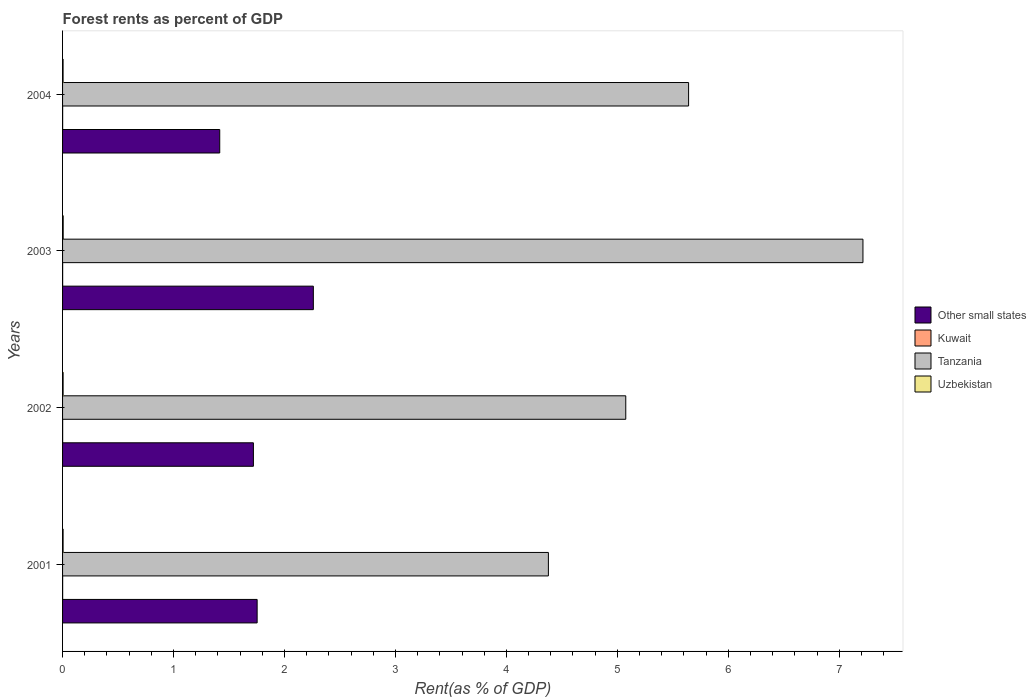How many groups of bars are there?
Make the answer very short. 4. Are the number of bars on each tick of the Y-axis equal?
Ensure brevity in your answer.  Yes. In how many cases, is the number of bars for a given year not equal to the number of legend labels?
Your answer should be compact. 0. What is the forest rent in Other small states in 2004?
Your answer should be compact. 1.42. Across all years, what is the maximum forest rent in Kuwait?
Your answer should be very brief. 0. Across all years, what is the minimum forest rent in Other small states?
Make the answer very short. 1.42. In which year was the forest rent in Other small states maximum?
Offer a very short reply. 2003. In which year was the forest rent in Other small states minimum?
Your response must be concise. 2004. What is the total forest rent in Tanzania in the graph?
Your answer should be very brief. 22.31. What is the difference between the forest rent in Tanzania in 2001 and that in 2003?
Offer a very short reply. -2.84. What is the difference between the forest rent in Kuwait in 2004 and the forest rent in Other small states in 2003?
Your response must be concise. -2.26. What is the average forest rent in Tanzania per year?
Make the answer very short. 5.58. In the year 2003, what is the difference between the forest rent in Kuwait and forest rent in Uzbekistan?
Give a very brief answer. -0. What is the ratio of the forest rent in Tanzania in 2001 to that in 2002?
Keep it short and to the point. 0.86. Is the forest rent in Tanzania in 2003 less than that in 2004?
Keep it short and to the point. No. What is the difference between the highest and the second highest forest rent in Kuwait?
Ensure brevity in your answer.  9.368478416305103e-5. What is the difference between the highest and the lowest forest rent in Tanzania?
Make the answer very short. 2.84. In how many years, is the forest rent in Uzbekistan greater than the average forest rent in Uzbekistan taken over all years?
Your response must be concise. 1. Is the sum of the forest rent in Kuwait in 2001 and 2003 greater than the maximum forest rent in Other small states across all years?
Offer a very short reply. No. What does the 4th bar from the top in 2002 represents?
Your response must be concise. Other small states. What does the 3rd bar from the bottom in 2001 represents?
Make the answer very short. Tanzania. Is it the case that in every year, the sum of the forest rent in Kuwait and forest rent in Tanzania is greater than the forest rent in Other small states?
Provide a short and direct response. Yes. Are all the bars in the graph horizontal?
Keep it short and to the point. Yes. What is the difference between two consecutive major ticks on the X-axis?
Your answer should be very brief. 1. Are the values on the major ticks of X-axis written in scientific E-notation?
Your answer should be compact. No. Does the graph contain grids?
Make the answer very short. No. Where does the legend appear in the graph?
Give a very brief answer. Center right. How many legend labels are there?
Provide a succinct answer. 4. What is the title of the graph?
Provide a short and direct response. Forest rents as percent of GDP. Does "Solomon Islands" appear as one of the legend labels in the graph?
Give a very brief answer. No. What is the label or title of the X-axis?
Offer a very short reply. Rent(as % of GDP). What is the label or title of the Y-axis?
Offer a terse response. Years. What is the Rent(as % of GDP) in Other small states in 2001?
Give a very brief answer. 1.75. What is the Rent(as % of GDP) of Kuwait in 2001?
Provide a short and direct response. 0. What is the Rent(as % of GDP) in Tanzania in 2001?
Ensure brevity in your answer.  4.38. What is the Rent(as % of GDP) in Uzbekistan in 2001?
Keep it short and to the point. 0. What is the Rent(as % of GDP) in Other small states in 2002?
Make the answer very short. 1.72. What is the Rent(as % of GDP) in Kuwait in 2002?
Give a very brief answer. 0. What is the Rent(as % of GDP) in Tanzania in 2002?
Provide a short and direct response. 5.08. What is the Rent(as % of GDP) in Uzbekistan in 2002?
Provide a short and direct response. 0. What is the Rent(as % of GDP) in Other small states in 2003?
Your response must be concise. 2.26. What is the Rent(as % of GDP) of Kuwait in 2003?
Your answer should be compact. 0. What is the Rent(as % of GDP) in Tanzania in 2003?
Provide a succinct answer. 7.21. What is the Rent(as % of GDP) of Uzbekistan in 2003?
Offer a terse response. 0.01. What is the Rent(as % of GDP) in Other small states in 2004?
Offer a terse response. 1.42. What is the Rent(as % of GDP) of Kuwait in 2004?
Ensure brevity in your answer.  0. What is the Rent(as % of GDP) in Tanzania in 2004?
Ensure brevity in your answer.  5.64. What is the Rent(as % of GDP) of Uzbekistan in 2004?
Keep it short and to the point. 0. Across all years, what is the maximum Rent(as % of GDP) of Other small states?
Make the answer very short. 2.26. Across all years, what is the maximum Rent(as % of GDP) of Kuwait?
Your answer should be compact. 0. Across all years, what is the maximum Rent(as % of GDP) of Tanzania?
Give a very brief answer. 7.21. Across all years, what is the maximum Rent(as % of GDP) of Uzbekistan?
Offer a terse response. 0.01. Across all years, what is the minimum Rent(as % of GDP) of Other small states?
Your response must be concise. 1.42. Across all years, what is the minimum Rent(as % of GDP) in Kuwait?
Keep it short and to the point. 0. Across all years, what is the minimum Rent(as % of GDP) in Tanzania?
Offer a very short reply. 4.38. Across all years, what is the minimum Rent(as % of GDP) in Uzbekistan?
Your answer should be very brief. 0. What is the total Rent(as % of GDP) in Other small states in the graph?
Make the answer very short. 7.15. What is the total Rent(as % of GDP) of Kuwait in the graph?
Make the answer very short. 0. What is the total Rent(as % of GDP) of Tanzania in the graph?
Your answer should be very brief. 22.31. What is the difference between the Rent(as % of GDP) in Other small states in 2001 and that in 2002?
Offer a terse response. 0.03. What is the difference between the Rent(as % of GDP) of Kuwait in 2001 and that in 2002?
Ensure brevity in your answer.  -0. What is the difference between the Rent(as % of GDP) in Tanzania in 2001 and that in 2002?
Provide a short and direct response. -0.7. What is the difference between the Rent(as % of GDP) of Uzbekistan in 2001 and that in 2002?
Give a very brief answer. -0. What is the difference between the Rent(as % of GDP) of Other small states in 2001 and that in 2003?
Give a very brief answer. -0.51. What is the difference between the Rent(as % of GDP) of Tanzania in 2001 and that in 2003?
Your response must be concise. -2.84. What is the difference between the Rent(as % of GDP) of Uzbekistan in 2001 and that in 2003?
Give a very brief answer. -0. What is the difference between the Rent(as % of GDP) in Other small states in 2001 and that in 2004?
Your answer should be very brief. 0.34. What is the difference between the Rent(as % of GDP) of Tanzania in 2001 and that in 2004?
Your response must be concise. -1.26. What is the difference between the Rent(as % of GDP) of Uzbekistan in 2001 and that in 2004?
Your response must be concise. 0. What is the difference between the Rent(as % of GDP) of Other small states in 2002 and that in 2003?
Make the answer very short. -0.54. What is the difference between the Rent(as % of GDP) in Kuwait in 2002 and that in 2003?
Provide a short and direct response. 0. What is the difference between the Rent(as % of GDP) of Tanzania in 2002 and that in 2003?
Your answer should be very brief. -2.14. What is the difference between the Rent(as % of GDP) of Uzbekistan in 2002 and that in 2003?
Give a very brief answer. -0. What is the difference between the Rent(as % of GDP) of Other small states in 2002 and that in 2004?
Ensure brevity in your answer.  0.3. What is the difference between the Rent(as % of GDP) of Tanzania in 2002 and that in 2004?
Provide a short and direct response. -0.57. What is the difference between the Rent(as % of GDP) in Other small states in 2003 and that in 2004?
Make the answer very short. 0.84. What is the difference between the Rent(as % of GDP) in Kuwait in 2003 and that in 2004?
Your answer should be compact. 0. What is the difference between the Rent(as % of GDP) of Tanzania in 2003 and that in 2004?
Provide a short and direct response. 1.57. What is the difference between the Rent(as % of GDP) in Other small states in 2001 and the Rent(as % of GDP) in Kuwait in 2002?
Keep it short and to the point. 1.75. What is the difference between the Rent(as % of GDP) of Other small states in 2001 and the Rent(as % of GDP) of Tanzania in 2002?
Give a very brief answer. -3.32. What is the difference between the Rent(as % of GDP) in Other small states in 2001 and the Rent(as % of GDP) in Uzbekistan in 2002?
Make the answer very short. 1.75. What is the difference between the Rent(as % of GDP) of Kuwait in 2001 and the Rent(as % of GDP) of Tanzania in 2002?
Keep it short and to the point. -5.08. What is the difference between the Rent(as % of GDP) in Kuwait in 2001 and the Rent(as % of GDP) in Uzbekistan in 2002?
Your answer should be compact. -0. What is the difference between the Rent(as % of GDP) in Tanzania in 2001 and the Rent(as % of GDP) in Uzbekistan in 2002?
Keep it short and to the point. 4.37. What is the difference between the Rent(as % of GDP) in Other small states in 2001 and the Rent(as % of GDP) in Kuwait in 2003?
Offer a terse response. 1.75. What is the difference between the Rent(as % of GDP) of Other small states in 2001 and the Rent(as % of GDP) of Tanzania in 2003?
Offer a terse response. -5.46. What is the difference between the Rent(as % of GDP) of Other small states in 2001 and the Rent(as % of GDP) of Uzbekistan in 2003?
Your answer should be compact. 1.75. What is the difference between the Rent(as % of GDP) in Kuwait in 2001 and the Rent(as % of GDP) in Tanzania in 2003?
Your answer should be very brief. -7.21. What is the difference between the Rent(as % of GDP) of Kuwait in 2001 and the Rent(as % of GDP) of Uzbekistan in 2003?
Give a very brief answer. -0.01. What is the difference between the Rent(as % of GDP) of Tanzania in 2001 and the Rent(as % of GDP) of Uzbekistan in 2003?
Your response must be concise. 4.37. What is the difference between the Rent(as % of GDP) of Other small states in 2001 and the Rent(as % of GDP) of Kuwait in 2004?
Provide a succinct answer. 1.75. What is the difference between the Rent(as % of GDP) in Other small states in 2001 and the Rent(as % of GDP) in Tanzania in 2004?
Keep it short and to the point. -3.89. What is the difference between the Rent(as % of GDP) in Other small states in 2001 and the Rent(as % of GDP) in Uzbekistan in 2004?
Give a very brief answer. 1.75. What is the difference between the Rent(as % of GDP) in Kuwait in 2001 and the Rent(as % of GDP) in Tanzania in 2004?
Your answer should be very brief. -5.64. What is the difference between the Rent(as % of GDP) in Kuwait in 2001 and the Rent(as % of GDP) in Uzbekistan in 2004?
Your answer should be very brief. -0. What is the difference between the Rent(as % of GDP) of Tanzania in 2001 and the Rent(as % of GDP) of Uzbekistan in 2004?
Keep it short and to the point. 4.37. What is the difference between the Rent(as % of GDP) of Other small states in 2002 and the Rent(as % of GDP) of Kuwait in 2003?
Make the answer very short. 1.72. What is the difference between the Rent(as % of GDP) of Other small states in 2002 and the Rent(as % of GDP) of Tanzania in 2003?
Keep it short and to the point. -5.49. What is the difference between the Rent(as % of GDP) in Other small states in 2002 and the Rent(as % of GDP) in Uzbekistan in 2003?
Your response must be concise. 1.71. What is the difference between the Rent(as % of GDP) of Kuwait in 2002 and the Rent(as % of GDP) of Tanzania in 2003?
Your answer should be compact. -7.21. What is the difference between the Rent(as % of GDP) in Kuwait in 2002 and the Rent(as % of GDP) in Uzbekistan in 2003?
Offer a very short reply. -0. What is the difference between the Rent(as % of GDP) in Tanzania in 2002 and the Rent(as % of GDP) in Uzbekistan in 2003?
Give a very brief answer. 5.07. What is the difference between the Rent(as % of GDP) in Other small states in 2002 and the Rent(as % of GDP) in Kuwait in 2004?
Ensure brevity in your answer.  1.72. What is the difference between the Rent(as % of GDP) in Other small states in 2002 and the Rent(as % of GDP) in Tanzania in 2004?
Give a very brief answer. -3.92. What is the difference between the Rent(as % of GDP) of Other small states in 2002 and the Rent(as % of GDP) of Uzbekistan in 2004?
Make the answer very short. 1.72. What is the difference between the Rent(as % of GDP) in Kuwait in 2002 and the Rent(as % of GDP) in Tanzania in 2004?
Provide a short and direct response. -5.64. What is the difference between the Rent(as % of GDP) of Kuwait in 2002 and the Rent(as % of GDP) of Uzbekistan in 2004?
Your answer should be very brief. -0. What is the difference between the Rent(as % of GDP) of Tanzania in 2002 and the Rent(as % of GDP) of Uzbekistan in 2004?
Your response must be concise. 5.07. What is the difference between the Rent(as % of GDP) of Other small states in 2003 and the Rent(as % of GDP) of Kuwait in 2004?
Your answer should be very brief. 2.26. What is the difference between the Rent(as % of GDP) in Other small states in 2003 and the Rent(as % of GDP) in Tanzania in 2004?
Provide a succinct answer. -3.38. What is the difference between the Rent(as % of GDP) of Other small states in 2003 and the Rent(as % of GDP) of Uzbekistan in 2004?
Ensure brevity in your answer.  2.26. What is the difference between the Rent(as % of GDP) of Kuwait in 2003 and the Rent(as % of GDP) of Tanzania in 2004?
Give a very brief answer. -5.64. What is the difference between the Rent(as % of GDP) in Kuwait in 2003 and the Rent(as % of GDP) in Uzbekistan in 2004?
Keep it short and to the point. -0. What is the difference between the Rent(as % of GDP) in Tanzania in 2003 and the Rent(as % of GDP) in Uzbekistan in 2004?
Your answer should be compact. 7.21. What is the average Rent(as % of GDP) in Other small states per year?
Give a very brief answer. 1.79. What is the average Rent(as % of GDP) of Kuwait per year?
Make the answer very short. 0. What is the average Rent(as % of GDP) in Tanzania per year?
Offer a very short reply. 5.58. What is the average Rent(as % of GDP) in Uzbekistan per year?
Make the answer very short. 0.01. In the year 2001, what is the difference between the Rent(as % of GDP) of Other small states and Rent(as % of GDP) of Kuwait?
Offer a very short reply. 1.75. In the year 2001, what is the difference between the Rent(as % of GDP) of Other small states and Rent(as % of GDP) of Tanzania?
Provide a short and direct response. -2.62. In the year 2001, what is the difference between the Rent(as % of GDP) in Other small states and Rent(as % of GDP) in Uzbekistan?
Ensure brevity in your answer.  1.75. In the year 2001, what is the difference between the Rent(as % of GDP) in Kuwait and Rent(as % of GDP) in Tanzania?
Your response must be concise. -4.38. In the year 2001, what is the difference between the Rent(as % of GDP) of Kuwait and Rent(as % of GDP) of Uzbekistan?
Your answer should be compact. -0. In the year 2001, what is the difference between the Rent(as % of GDP) in Tanzania and Rent(as % of GDP) in Uzbekistan?
Make the answer very short. 4.37. In the year 2002, what is the difference between the Rent(as % of GDP) of Other small states and Rent(as % of GDP) of Kuwait?
Keep it short and to the point. 1.72. In the year 2002, what is the difference between the Rent(as % of GDP) of Other small states and Rent(as % of GDP) of Tanzania?
Provide a short and direct response. -3.36. In the year 2002, what is the difference between the Rent(as % of GDP) in Other small states and Rent(as % of GDP) in Uzbekistan?
Offer a very short reply. 1.72. In the year 2002, what is the difference between the Rent(as % of GDP) in Kuwait and Rent(as % of GDP) in Tanzania?
Give a very brief answer. -5.08. In the year 2002, what is the difference between the Rent(as % of GDP) in Kuwait and Rent(as % of GDP) in Uzbekistan?
Offer a very short reply. -0. In the year 2002, what is the difference between the Rent(as % of GDP) of Tanzania and Rent(as % of GDP) of Uzbekistan?
Your answer should be compact. 5.07. In the year 2003, what is the difference between the Rent(as % of GDP) of Other small states and Rent(as % of GDP) of Kuwait?
Your response must be concise. 2.26. In the year 2003, what is the difference between the Rent(as % of GDP) of Other small states and Rent(as % of GDP) of Tanzania?
Provide a succinct answer. -4.95. In the year 2003, what is the difference between the Rent(as % of GDP) in Other small states and Rent(as % of GDP) in Uzbekistan?
Your answer should be compact. 2.25. In the year 2003, what is the difference between the Rent(as % of GDP) of Kuwait and Rent(as % of GDP) of Tanzania?
Give a very brief answer. -7.21. In the year 2003, what is the difference between the Rent(as % of GDP) of Kuwait and Rent(as % of GDP) of Uzbekistan?
Offer a terse response. -0.01. In the year 2003, what is the difference between the Rent(as % of GDP) of Tanzania and Rent(as % of GDP) of Uzbekistan?
Make the answer very short. 7.21. In the year 2004, what is the difference between the Rent(as % of GDP) of Other small states and Rent(as % of GDP) of Kuwait?
Offer a very short reply. 1.42. In the year 2004, what is the difference between the Rent(as % of GDP) in Other small states and Rent(as % of GDP) in Tanzania?
Make the answer very short. -4.23. In the year 2004, what is the difference between the Rent(as % of GDP) of Other small states and Rent(as % of GDP) of Uzbekistan?
Provide a short and direct response. 1.41. In the year 2004, what is the difference between the Rent(as % of GDP) in Kuwait and Rent(as % of GDP) in Tanzania?
Keep it short and to the point. -5.64. In the year 2004, what is the difference between the Rent(as % of GDP) of Kuwait and Rent(as % of GDP) of Uzbekistan?
Ensure brevity in your answer.  -0. In the year 2004, what is the difference between the Rent(as % of GDP) of Tanzania and Rent(as % of GDP) of Uzbekistan?
Provide a succinct answer. 5.64. What is the ratio of the Rent(as % of GDP) of Other small states in 2001 to that in 2002?
Your response must be concise. 1.02. What is the ratio of the Rent(as % of GDP) in Kuwait in 2001 to that in 2002?
Offer a very short reply. 0.88. What is the ratio of the Rent(as % of GDP) in Tanzania in 2001 to that in 2002?
Your response must be concise. 0.86. What is the ratio of the Rent(as % of GDP) in Other small states in 2001 to that in 2003?
Make the answer very short. 0.78. What is the ratio of the Rent(as % of GDP) of Kuwait in 2001 to that in 2003?
Offer a very short reply. 1.02. What is the ratio of the Rent(as % of GDP) in Tanzania in 2001 to that in 2003?
Offer a terse response. 0.61. What is the ratio of the Rent(as % of GDP) in Uzbekistan in 2001 to that in 2003?
Your response must be concise. 0.83. What is the ratio of the Rent(as % of GDP) in Other small states in 2001 to that in 2004?
Keep it short and to the point. 1.24. What is the ratio of the Rent(as % of GDP) in Kuwait in 2001 to that in 2004?
Your answer should be compact. 1.11. What is the ratio of the Rent(as % of GDP) in Tanzania in 2001 to that in 2004?
Give a very brief answer. 0.78. What is the ratio of the Rent(as % of GDP) of Uzbekistan in 2001 to that in 2004?
Your response must be concise. 1.01. What is the ratio of the Rent(as % of GDP) in Other small states in 2002 to that in 2003?
Provide a short and direct response. 0.76. What is the ratio of the Rent(as % of GDP) of Kuwait in 2002 to that in 2003?
Offer a terse response. 1.16. What is the ratio of the Rent(as % of GDP) of Tanzania in 2002 to that in 2003?
Your answer should be very brief. 0.7. What is the ratio of the Rent(as % of GDP) in Uzbekistan in 2002 to that in 2003?
Make the answer very short. 0.87. What is the ratio of the Rent(as % of GDP) of Other small states in 2002 to that in 2004?
Ensure brevity in your answer.  1.21. What is the ratio of the Rent(as % of GDP) of Kuwait in 2002 to that in 2004?
Make the answer very short. 1.26. What is the ratio of the Rent(as % of GDP) in Tanzania in 2002 to that in 2004?
Make the answer very short. 0.9. What is the ratio of the Rent(as % of GDP) in Uzbekistan in 2002 to that in 2004?
Provide a succinct answer. 1.06. What is the ratio of the Rent(as % of GDP) of Other small states in 2003 to that in 2004?
Ensure brevity in your answer.  1.6. What is the ratio of the Rent(as % of GDP) in Kuwait in 2003 to that in 2004?
Keep it short and to the point. 1.09. What is the ratio of the Rent(as % of GDP) in Tanzania in 2003 to that in 2004?
Offer a very short reply. 1.28. What is the ratio of the Rent(as % of GDP) in Uzbekistan in 2003 to that in 2004?
Your response must be concise. 1.21. What is the difference between the highest and the second highest Rent(as % of GDP) in Other small states?
Provide a short and direct response. 0.51. What is the difference between the highest and the second highest Rent(as % of GDP) of Kuwait?
Your response must be concise. 0. What is the difference between the highest and the second highest Rent(as % of GDP) in Tanzania?
Provide a short and direct response. 1.57. What is the difference between the highest and the second highest Rent(as % of GDP) in Uzbekistan?
Offer a terse response. 0. What is the difference between the highest and the lowest Rent(as % of GDP) in Other small states?
Offer a terse response. 0.84. What is the difference between the highest and the lowest Rent(as % of GDP) in Kuwait?
Make the answer very short. 0. What is the difference between the highest and the lowest Rent(as % of GDP) of Tanzania?
Provide a succinct answer. 2.84. 